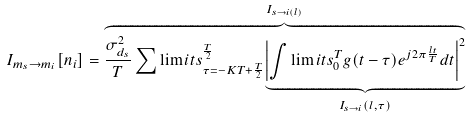Convert formula to latex. <formula><loc_0><loc_0><loc_500><loc_500>I _ { m _ { s } \rightarrow m _ { i } } [ n _ { i } ] & = \overset { I _ { s \rightarrow i ( l ) } } { \overbrace { \frac { \sigma _ { d _ { s } } ^ { 2 } } { T } \sum \lim i t s _ { \tau = - K T + \frac { T } { 2 } } ^ { \frac { T } { 2 } } \underset { I _ { s \rightarrow i } ( l , \tau ) } { \underbrace { \left | \int \lim i t s _ { 0 } ^ { T } g ( t - \tau ) e ^ { j 2 \pi \frac { l t } { T } } d t \right | ^ { 2 } } } } }</formula> 